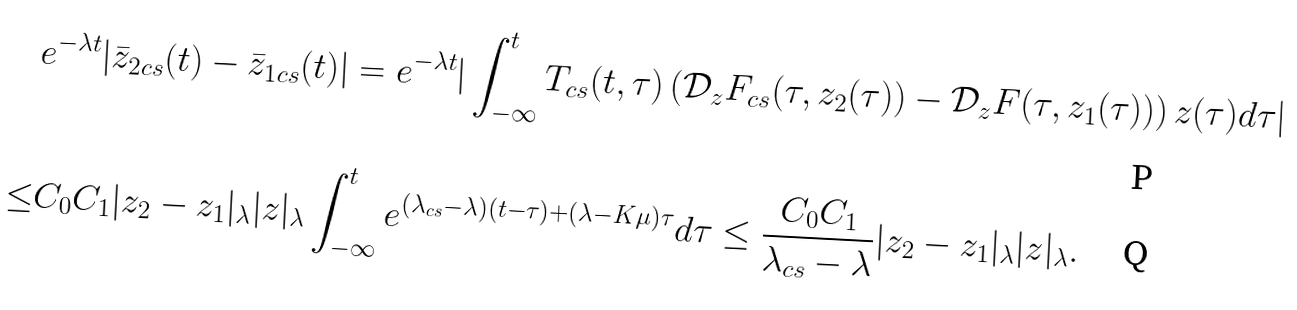<formula> <loc_0><loc_0><loc_500><loc_500>& e ^ { - \lambda t } | \bar { z } _ { 2 c s } ( t ) - \bar { z } _ { 1 c s } ( t ) | = e ^ { - \lambda t } | \int _ { - \infty } ^ { t } T _ { c s } ( t , \tau ) \left ( \mathcal { D } _ { z } F _ { c s } ( \tau , z _ { 2 } ( \tau ) ) - \mathcal { D } _ { z } F ( \tau , z _ { 1 } ( \tau ) ) \right ) z ( \tau ) d \tau | \\ \leq & C _ { 0 } C _ { 1 } | z _ { 2 } - z _ { 1 } | _ { \lambda } | z | _ { \lambda } \int _ { - \infty } ^ { t } e ^ { ( \lambda _ { c s } - \lambda ) ( t - \tau ) + ( \lambda - K \mu ) \tau } d \tau \leq \frac { C _ { 0 } C _ { 1 } } { \lambda _ { c s } - \lambda } | z _ { 2 } - z _ { 1 } | _ { \lambda } | z | _ { \lambda } .</formula> 